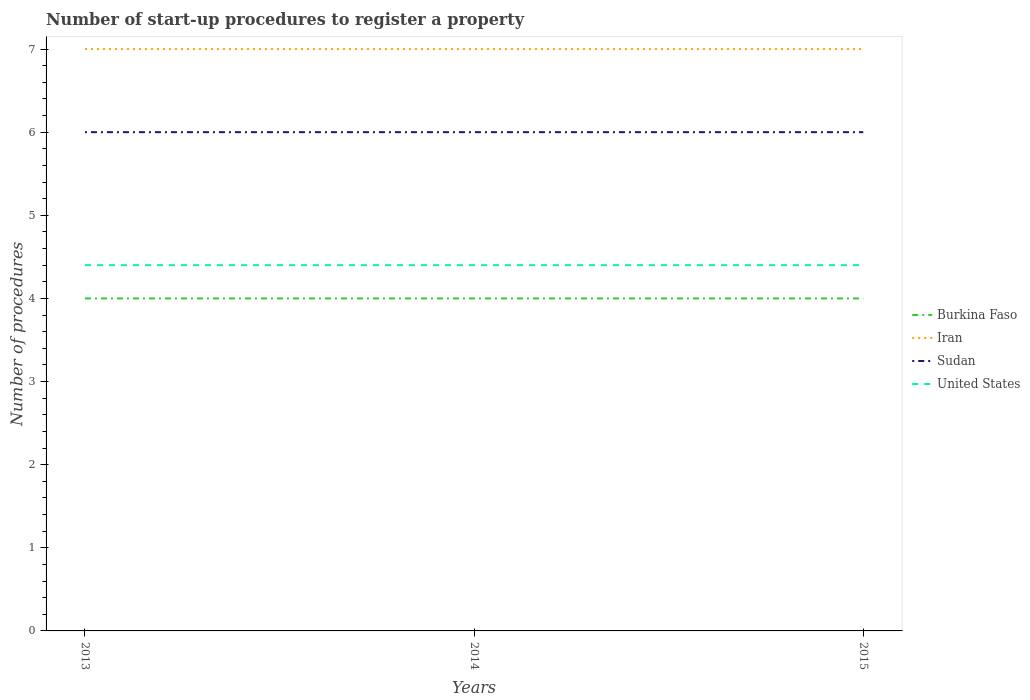How many different coloured lines are there?
Ensure brevity in your answer.  4. Does the line corresponding to United States intersect with the line corresponding to Iran?
Keep it short and to the point. No. Across all years, what is the maximum number of procedures required to register a property in Iran?
Keep it short and to the point. 7. Is the number of procedures required to register a property in Sudan strictly greater than the number of procedures required to register a property in United States over the years?
Your response must be concise. No. How many lines are there?
Give a very brief answer. 4. How many years are there in the graph?
Offer a terse response. 3. What is the difference between two consecutive major ticks on the Y-axis?
Offer a very short reply. 1. Are the values on the major ticks of Y-axis written in scientific E-notation?
Offer a very short reply. No. Does the graph contain any zero values?
Make the answer very short. No. Does the graph contain grids?
Provide a short and direct response. No. How many legend labels are there?
Ensure brevity in your answer.  4. How are the legend labels stacked?
Give a very brief answer. Vertical. What is the title of the graph?
Your answer should be very brief. Number of start-up procedures to register a property. What is the label or title of the X-axis?
Give a very brief answer. Years. What is the label or title of the Y-axis?
Provide a short and direct response. Number of procedures. What is the Number of procedures of Iran in 2013?
Your response must be concise. 7. What is the Number of procedures in Burkina Faso in 2014?
Provide a short and direct response. 4. What is the Number of procedures of Iran in 2014?
Make the answer very short. 7. What is the Number of procedures of Sudan in 2014?
Provide a short and direct response. 6. What is the Number of procedures in United States in 2014?
Provide a short and direct response. 4.4. What is the Number of procedures in Sudan in 2015?
Provide a succinct answer. 6. What is the Number of procedures of United States in 2015?
Your answer should be compact. 4.4. Across all years, what is the maximum Number of procedures in Burkina Faso?
Ensure brevity in your answer.  4. Across all years, what is the maximum Number of procedures in Iran?
Give a very brief answer. 7. Across all years, what is the maximum Number of procedures of United States?
Your answer should be very brief. 4.4. Across all years, what is the minimum Number of procedures of Burkina Faso?
Offer a very short reply. 4. What is the total Number of procedures of Burkina Faso in the graph?
Provide a short and direct response. 12. What is the total Number of procedures in Sudan in the graph?
Ensure brevity in your answer.  18. What is the total Number of procedures of United States in the graph?
Make the answer very short. 13.2. What is the difference between the Number of procedures of Burkina Faso in 2013 and that in 2014?
Provide a succinct answer. 0. What is the difference between the Number of procedures in Sudan in 2013 and that in 2014?
Make the answer very short. 0. What is the difference between the Number of procedures in United States in 2013 and that in 2014?
Your answer should be very brief. 0. What is the difference between the Number of procedures in Iran in 2013 and that in 2015?
Your answer should be compact. 0. What is the difference between the Number of procedures of Sudan in 2013 and that in 2015?
Make the answer very short. 0. What is the difference between the Number of procedures of Burkina Faso in 2013 and the Number of procedures of Iran in 2014?
Provide a succinct answer. -3. What is the difference between the Number of procedures of Burkina Faso in 2013 and the Number of procedures of Sudan in 2014?
Provide a short and direct response. -2. What is the difference between the Number of procedures of Burkina Faso in 2013 and the Number of procedures of Sudan in 2015?
Provide a short and direct response. -2. What is the difference between the Number of procedures in Burkina Faso in 2013 and the Number of procedures in United States in 2015?
Your answer should be compact. -0.4. What is the difference between the Number of procedures of Sudan in 2013 and the Number of procedures of United States in 2015?
Provide a succinct answer. 1.6. What is the difference between the Number of procedures of Burkina Faso in 2014 and the Number of procedures of Iran in 2015?
Ensure brevity in your answer.  -3. What is the difference between the Number of procedures in Burkina Faso in 2014 and the Number of procedures in United States in 2015?
Give a very brief answer. -0.4. What is the difference between the Number of procedures in Iran in 2014 and the Number of procedures in Sudan in 2015?
Your answer should be compact. 1. What is the difference between the Number of procedures in Iran in 2014 and the Number of procedures in United States in 2015?
Keep it short and to the point. 2.6. What is the average Number of procedures of Burkina Faso per year?
Your answer should be compact. 4. What is the average Number of procedures in Iran per year?
Your response must be concise. 7. What is the average Number of procedures in Sudan per year?
Give a very brief answer. 6. What is the average Number of procedures of United States per year?
Your response must be concise. 4.4. In the year 2013, what is the difference between the Number of procedures of Burkina Faso and Number of procedures of Iran?
Provide a succinct answer. -3. In the year 2013, what is the difference between the Number of procedures in Burkina Faso and Number of procedures in United States?
Your answer should be compact. -0.4. In the year 2013, what is the difference between the Number of procedures of Iran and Number of procedures of Sudan?
Your answer should be compact. 1. In the year 2013, what is the difference between the Number of procedures in Sudan and Number of procedures in United States?
Provide a succinct answer. 1.6. In the year 2014, what is the difference between the Number of procedures in Burkina Faso and Number of procedures in Sudan?
Your answer should be very brief. -2. In the year 2014, what is the difference between the Number of procedures of Sudan and Number of procedures of United States?
Ensure brevity in your answer.  1.6. In the year 2015, what is the difference between the Number of procedures in Burkina Faso and Number of procedures in Iran?
Ensure brevity in your answer.  -3. In the year 2015, what is the difference between the Number of procedures of Burkina Faso and Number of procedures of Sudan?
Keep it short and to the point. -2. In the year 2015, what is the difference between the Number of procedures in Burkina Faso and Number of procedures in United States?
Offer a terse response. -0.4. In the year 2015, what is the difference between the Number of procedures of Iran and Number of procedures of Sudan?
Your answer should be very brief. 1. In the year 2015, what is the difference between the Number of procedures of Sudan and Number of procedures of United States?
Your answer should be very brief. 1.6. What is the ratio of the Number of procedures of Iran in 2013 to that in 2014?
Ensure brevity in your answer.  1. What is the ratio of the Number of procedures in Sudan in 2013 to that in 2014?
Your answer should be very brief. 1. What is the ratio of the Number of procedures in Burkina Faso in 2013 to that in 2015?
Your answer should be very brief. 1. What is the ratio of the Number of procedures of Sudan in 2013 to that in 2015?
Your response must be concise. 1. What is the ratio of the Number of procedures of Burkina Faso in 2014 to that in 2015?
Offer a terse response. 1. What is the difference between the highest and the second highest Number of procedures of Burkina Faso?
Ensure brevity in your answer.  0. What is the difference between the highest and the second highest Number of procedures in Iran?
Offer a very short reply. 0. What is the difference between the highest and the second highest Number of procedures of United States?
Your answer should be very brief. 0. What is the difference between the highest and the lowest Number of procedures of Burkina Faso?
Your answer should be very brief. 0. What is the difference between the highest and the lowest Number of procedures of United States?
Make the answer very short. 0. 